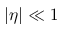Convert formula to latex. <formula><loc_0><loc_0><loc_500><loc_500>| \eta | \ll 1</formula> 